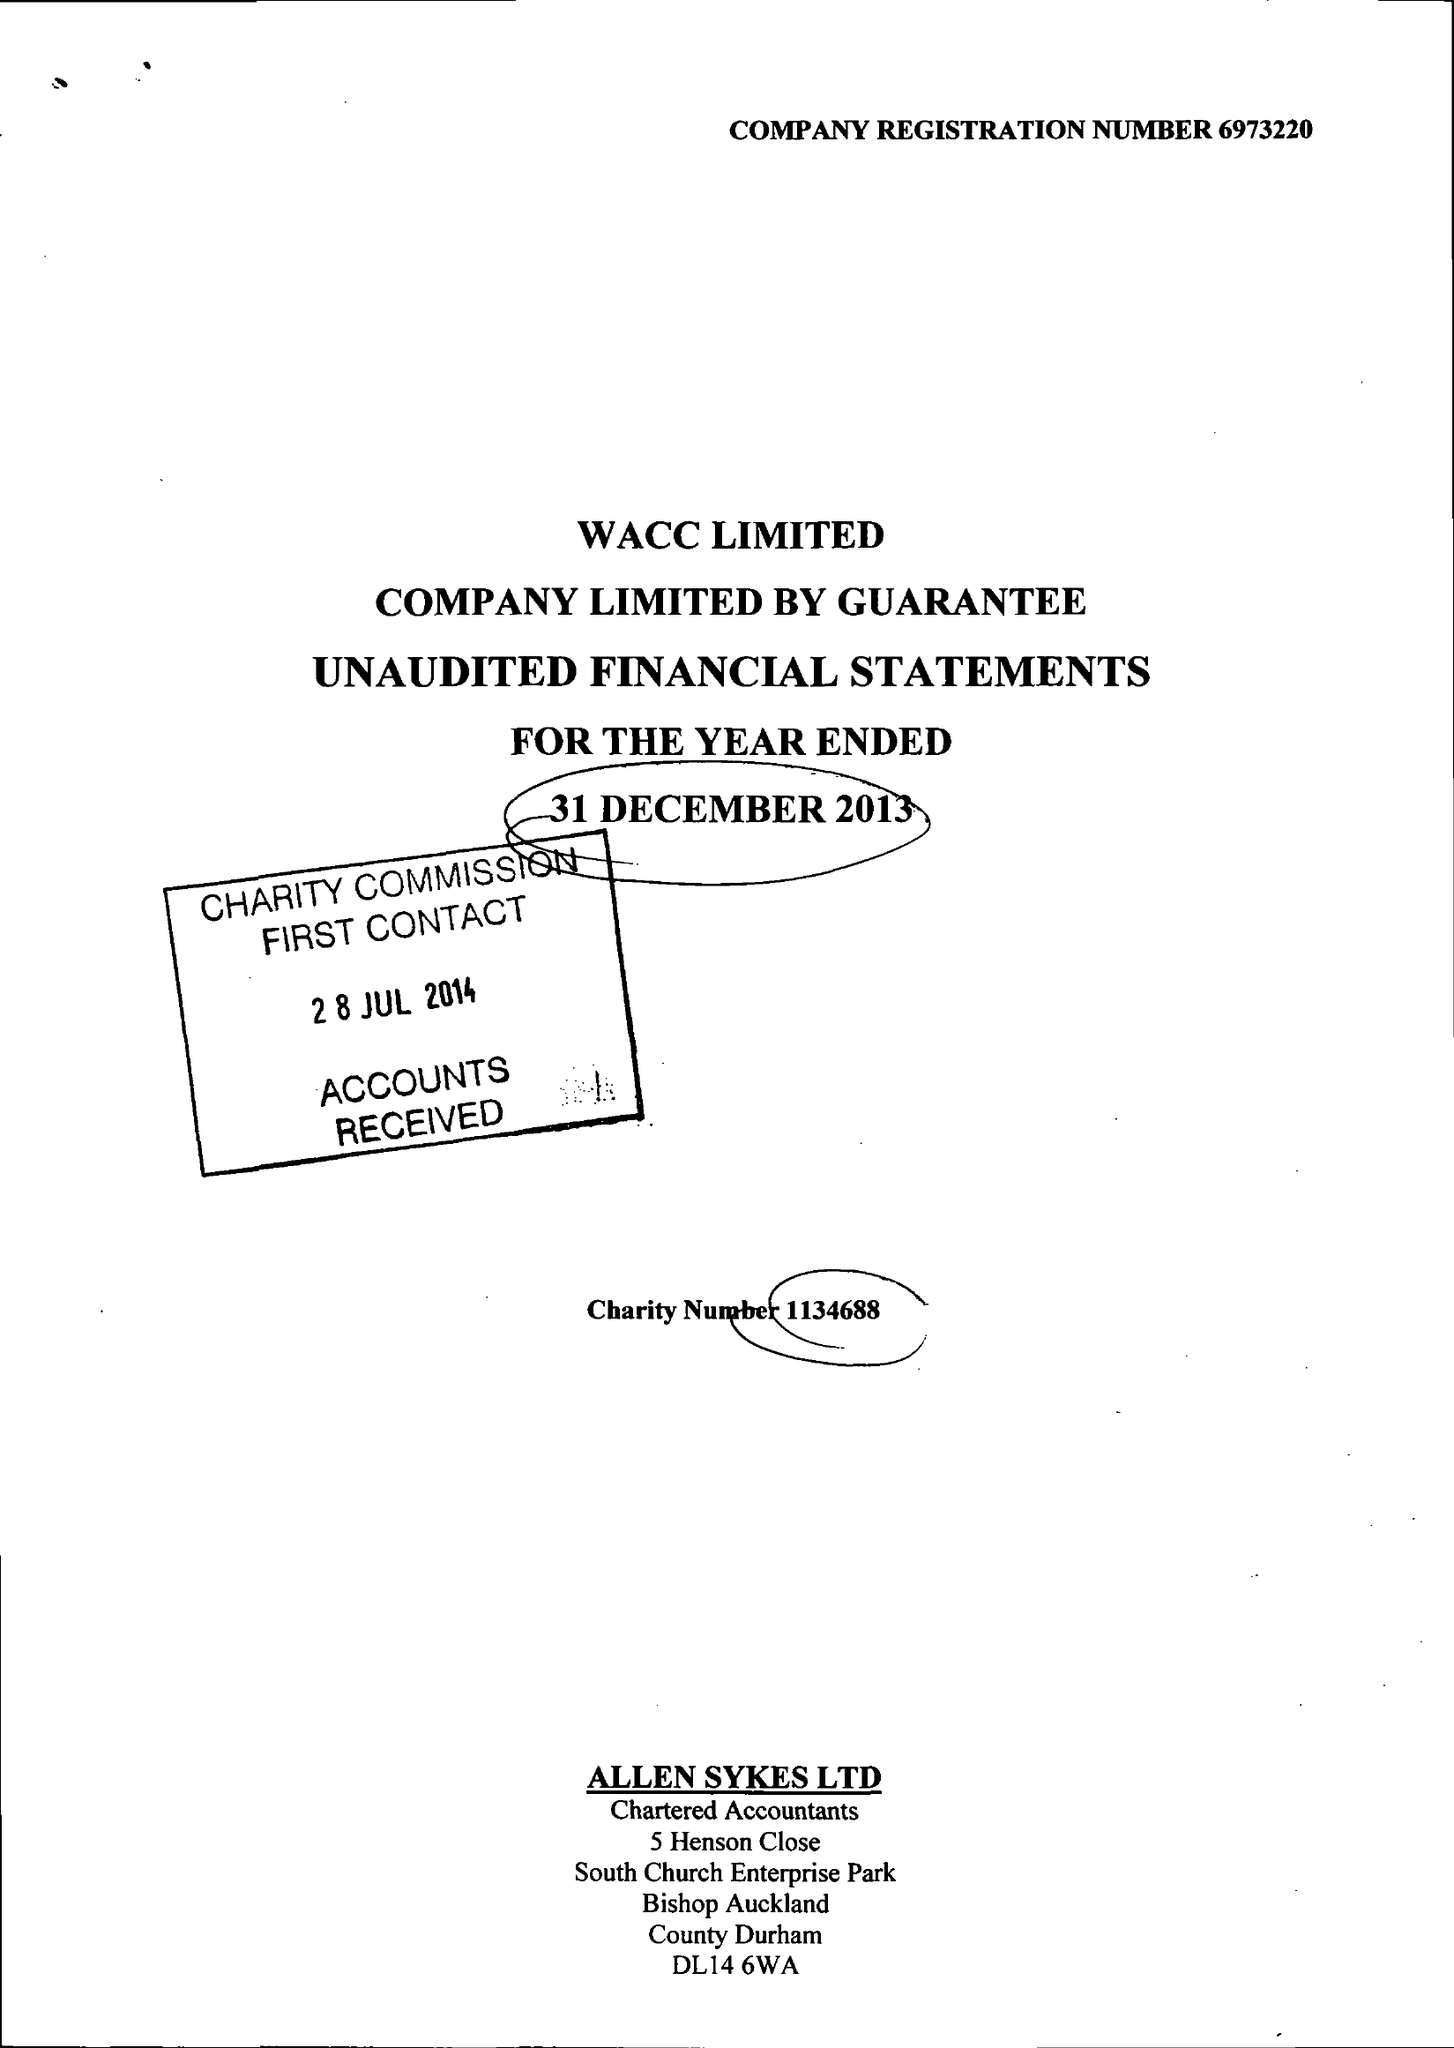What is the value for the income_annually_in_british_pounds?
Answer the question using a single word or phrase. 77882.00 